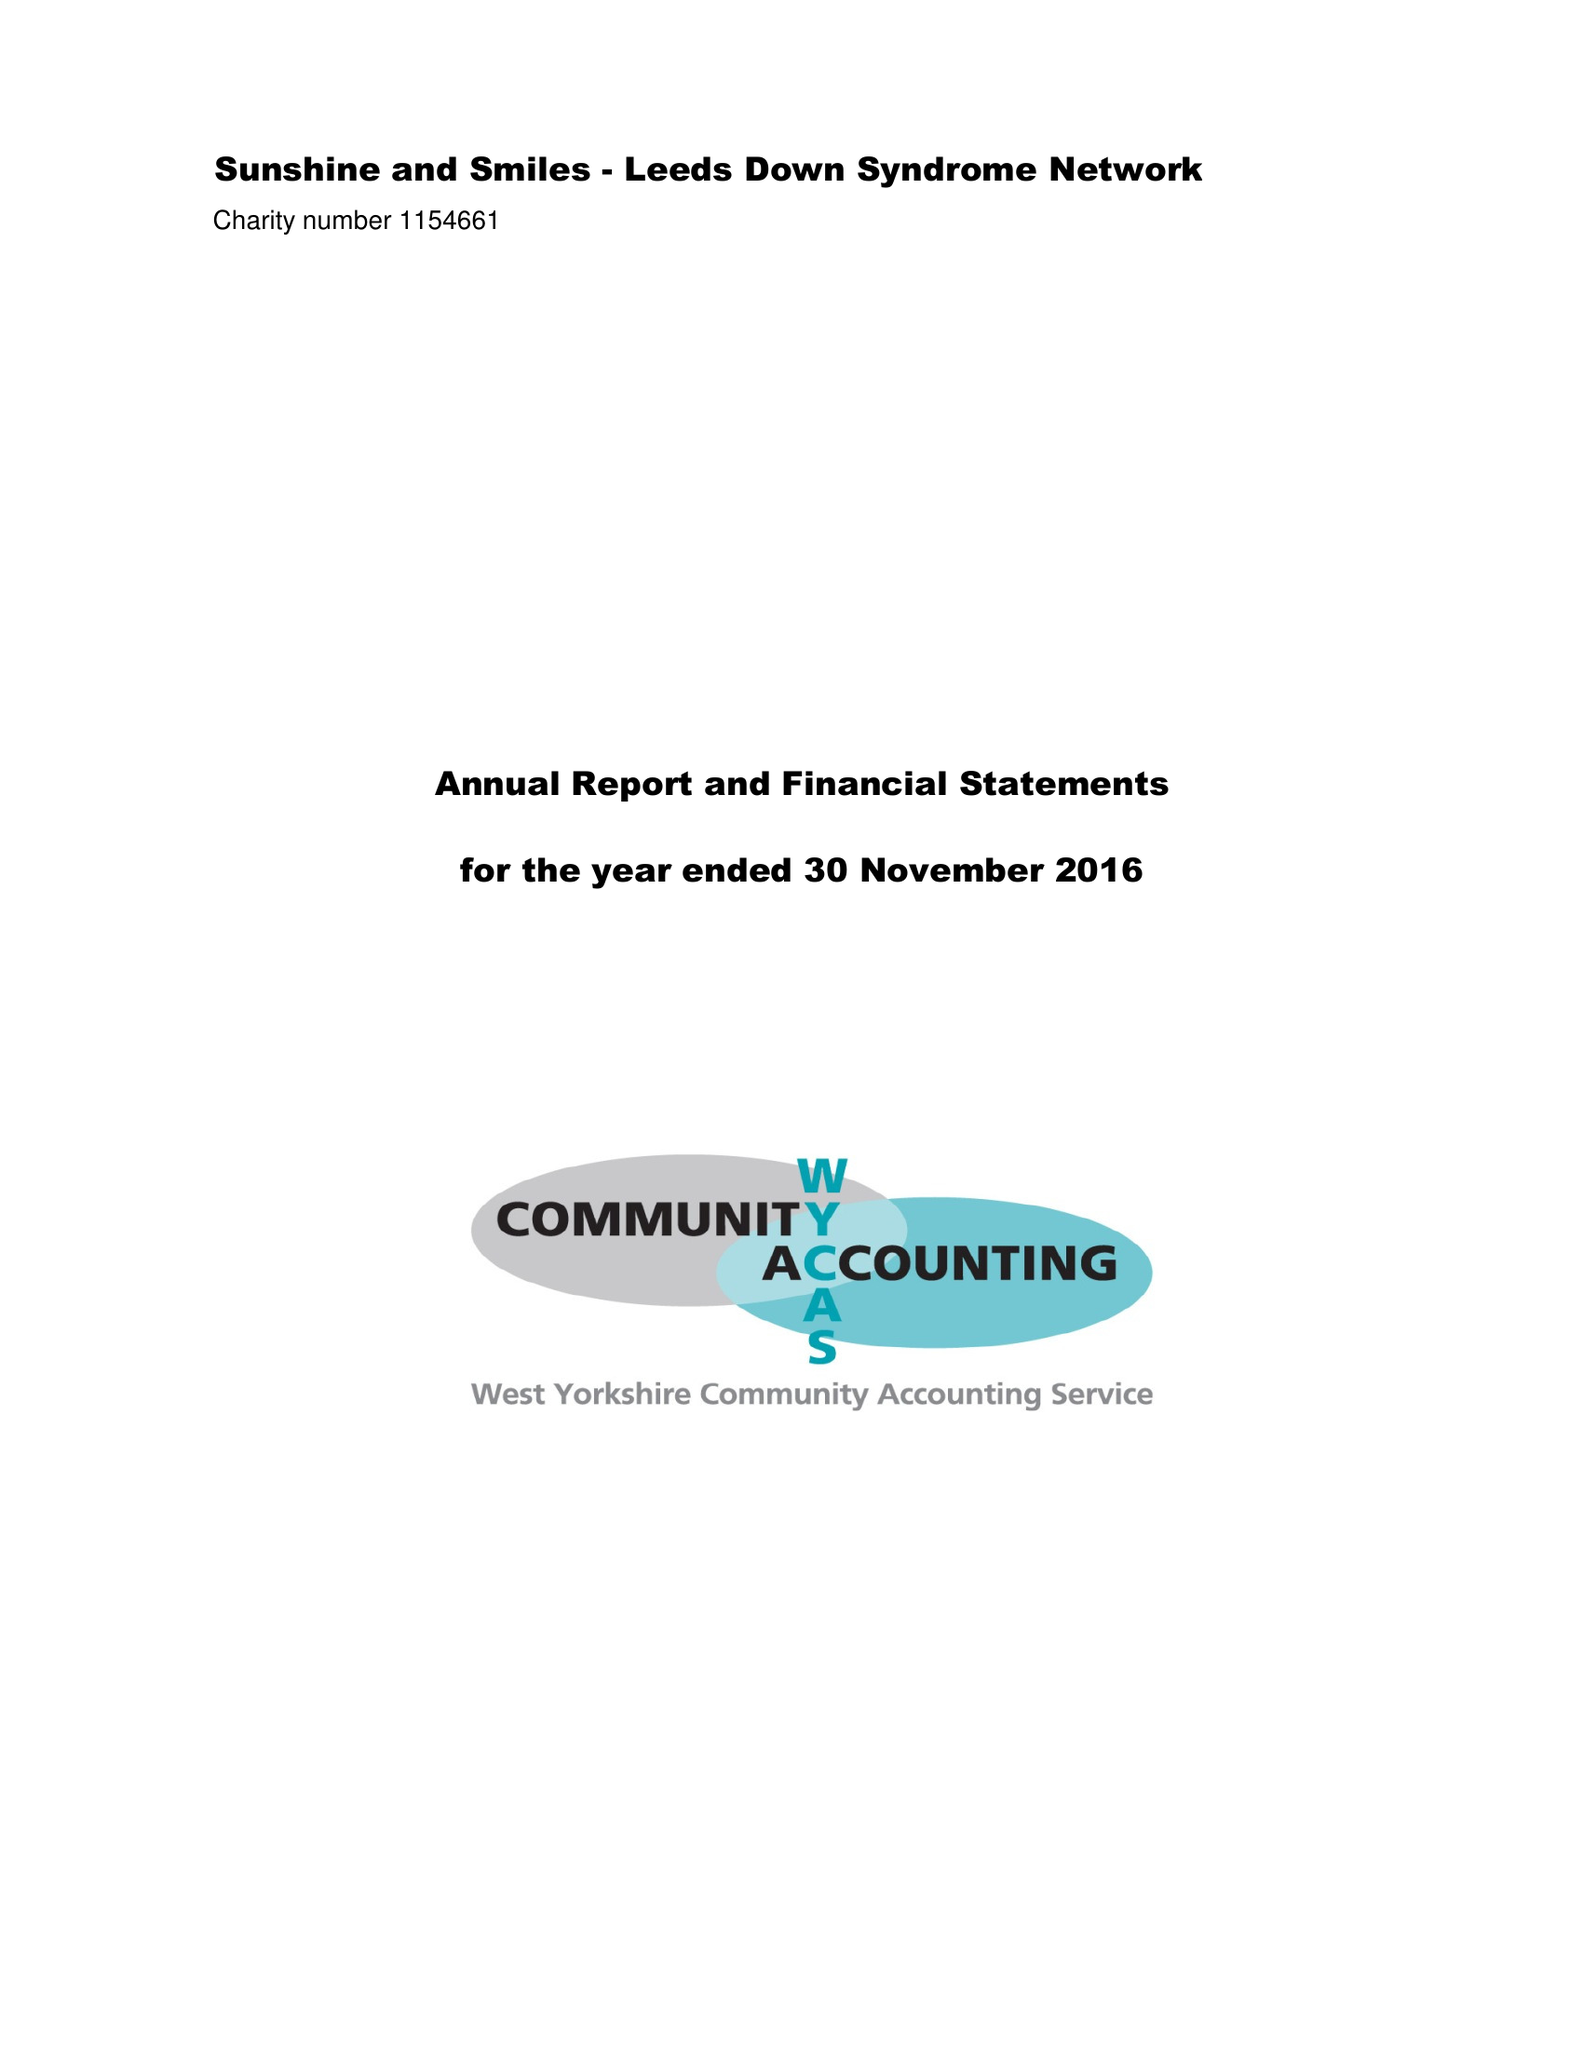What is the value for the charity_number?
Answer the question using a single word or phrase. 1154661 